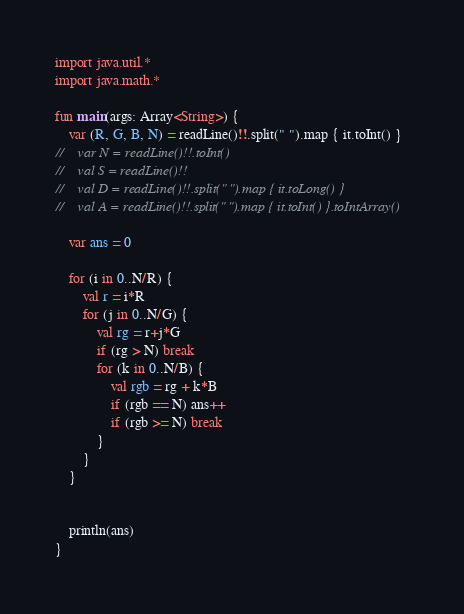<code> <loc_0><loc_0><loc_500><loc_500><_Kotlin_>import java.util.*
import java.math.*

fun main(args: Array<String>) {
    var (R, G, B, N) = readLine()!!.split(" ").map { it.toInt() }
//    var N = readLine()!!.toInt()
//    val S = readLine()!!
//    val D = readLine()!!.split(" ").map { it.toLong() }
//    val A = readLine()!!.split(" ").map { it.toInt() }.toIntArray()

    var ans = 0

    for (i in 0..N/R) {
        val r = i*R
        for (j in 0..N/G) {
            val rg = r+j*G
            if (rg > N) break
            for (k in 0..N/B) {
                val rgb = rg + k*B
                if (rgb == N) ans++
                if (rgb >= N) break
            }
        }
    }


    println(ans)
}
</code> 